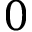<formula> <loc_0><loc_0><loc_500><loc_500>0</formula> 